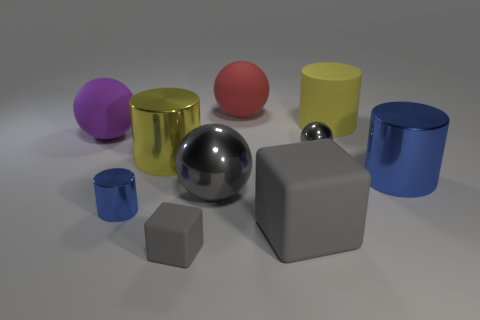Is the shape of the large purple matte object the same as the red thing? yes 